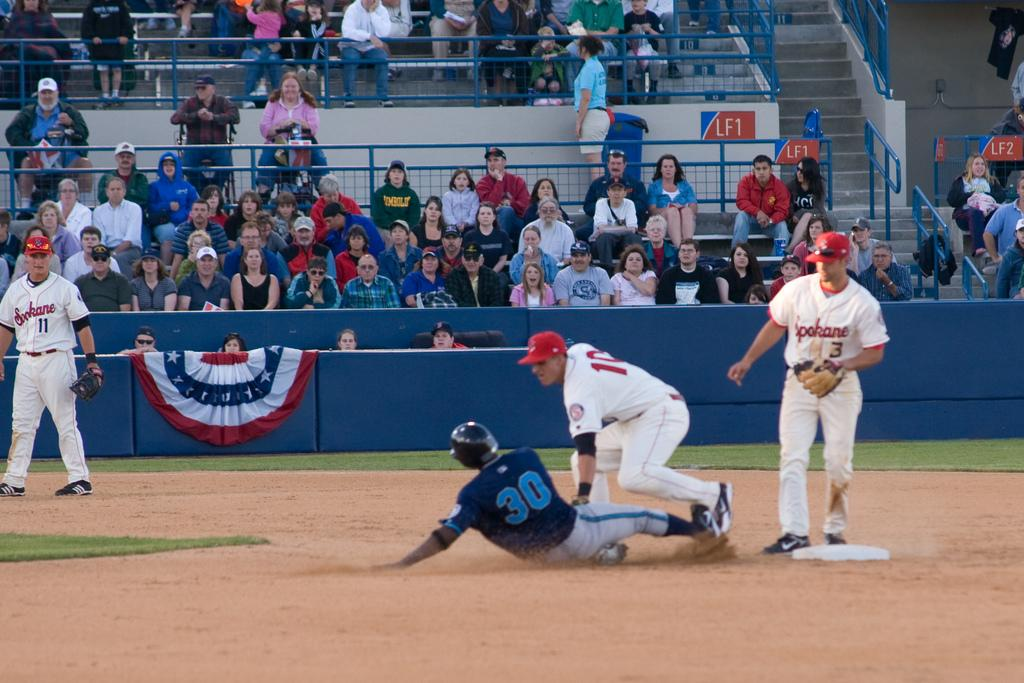<image>
Create a compact narrative representing the image presented. number 30 of the blue team is sliding to base 